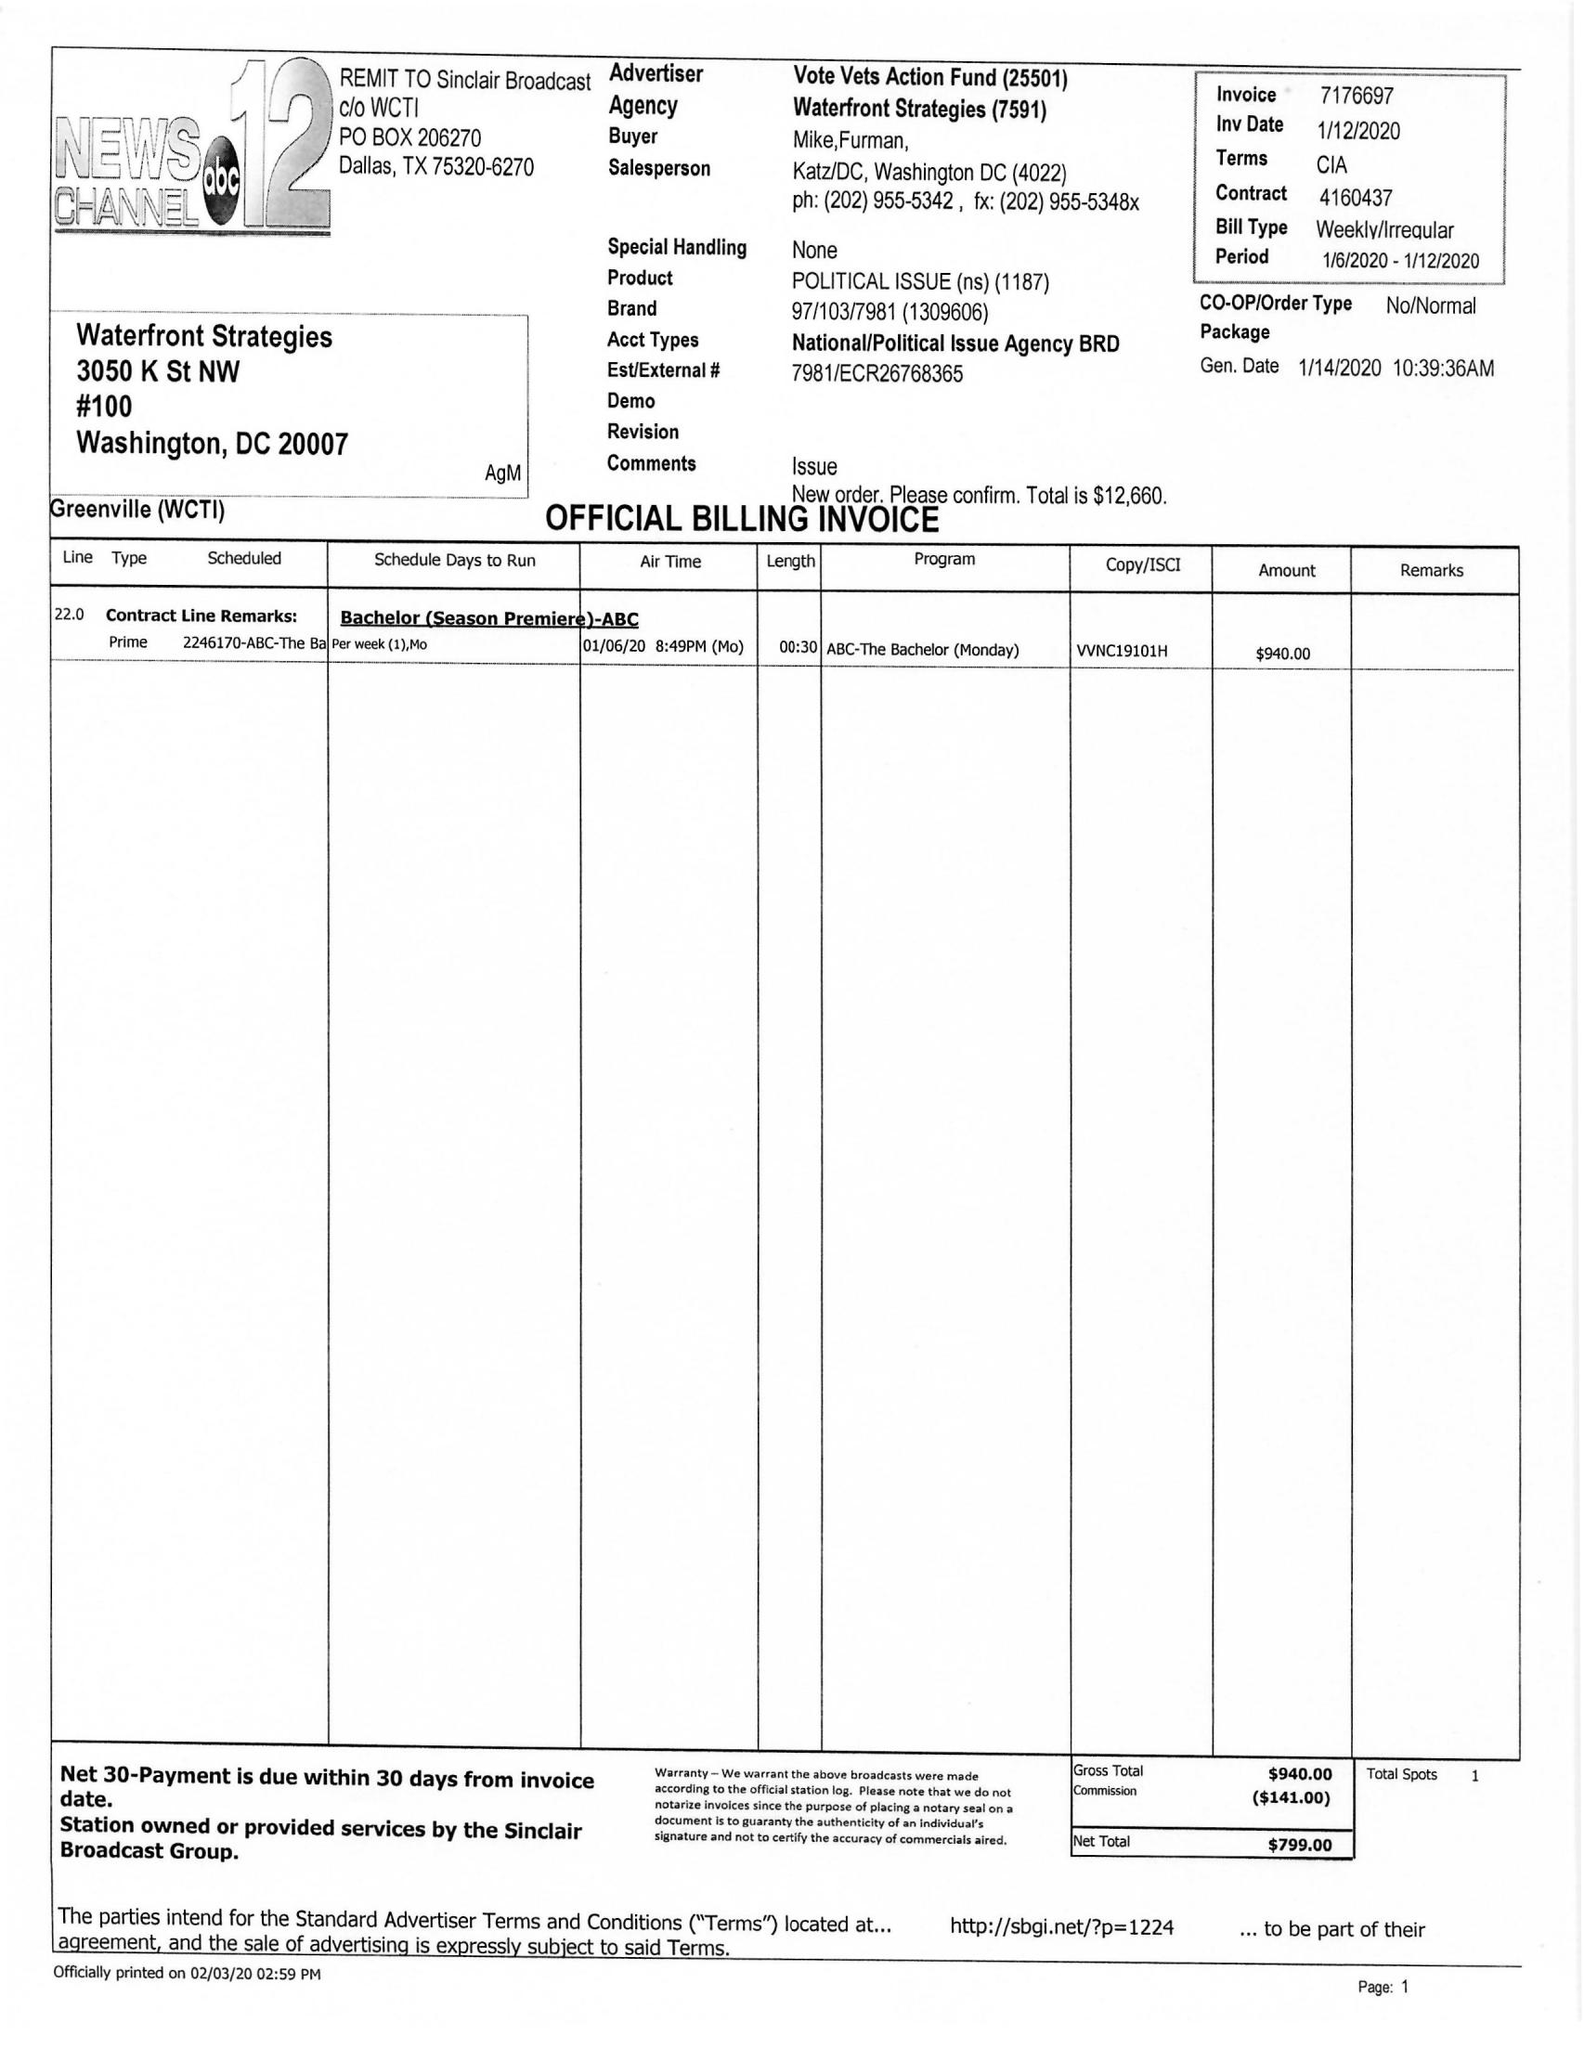What is the value for the contract_num?
Answer the question using a single word or phrase. 416043 